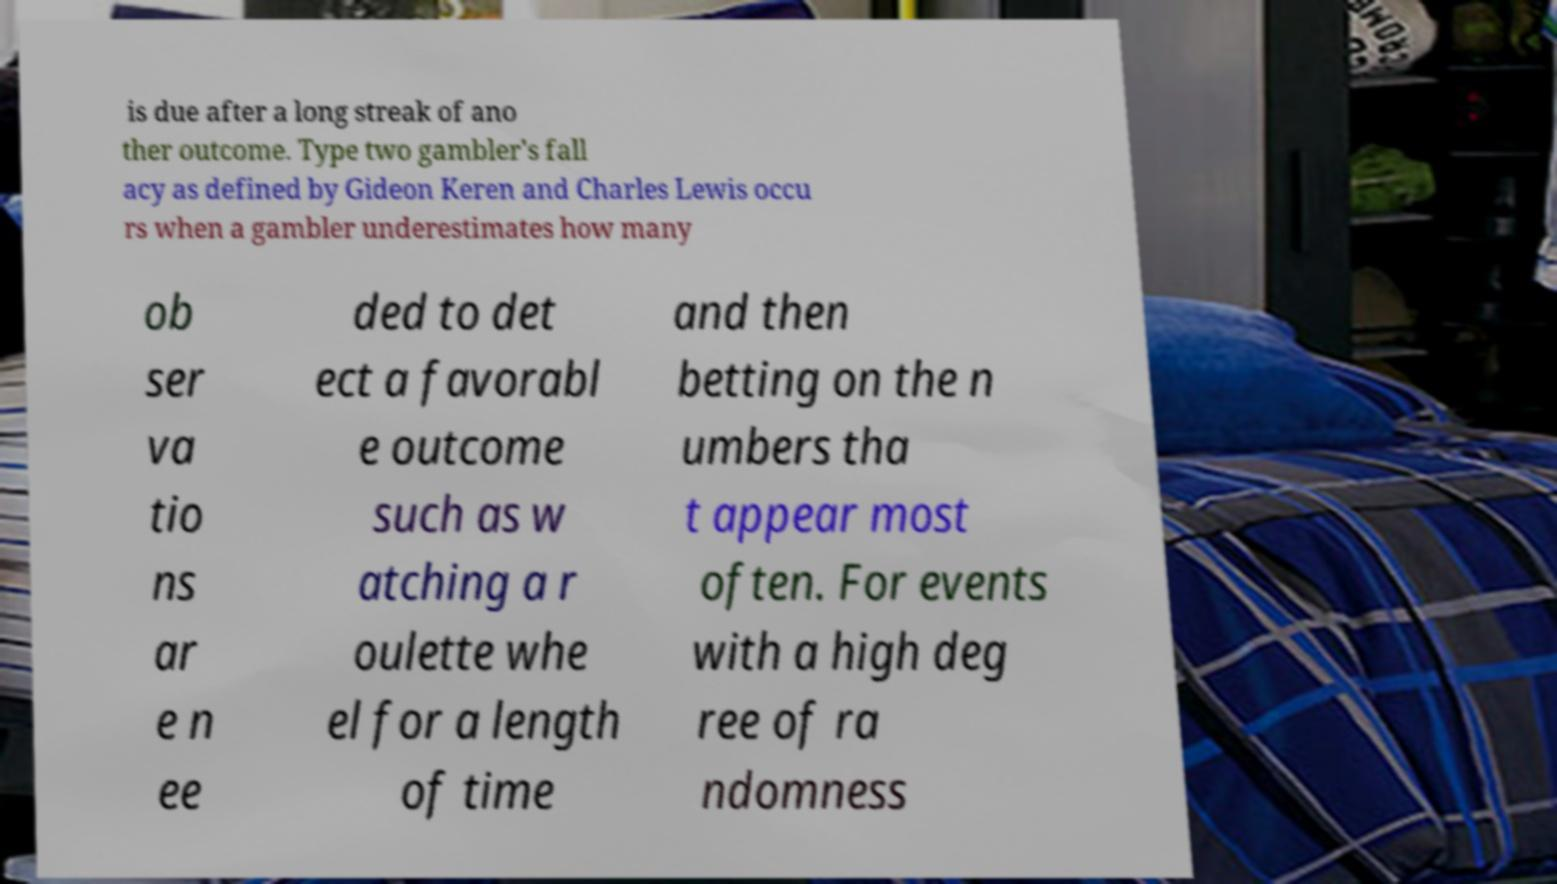Please identify and transcribe the text found in this image. is due after a long streak of ano ther outcome. Type two gambler's fall acy as defined by Gideon Keren and Charles Lewis occu rs when a gambler underestimates how many ob ser va tio ns ar e n ee ded to det ect a favorabl e outcome such as w atching a r oulette whe el for a length of time and then betting on the n umbers tha t appear most often. For events with a high deg ree of ra ndomness 